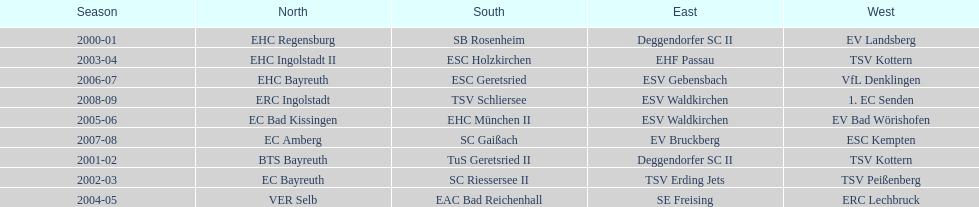Which moniker is more frequent, kottern or bayreuth? Bayreuth. 